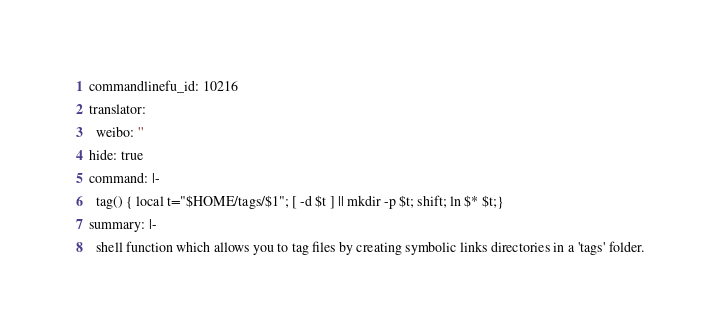<code> <loc_0><loc_0><loc_500><loc_500><_YAML_>commandlinefu_id: 10216
translator:
  weibo: ''
hide: true
command: |-
  tag() { local t="$HOME/tags/$1"; [ -d $t ] || mkdir -p $t; shift; ln $* $t;}
summary: |-
  shell function which allows you to tag files by creating symbolic links directories in a 'tags' folder.
</code> 